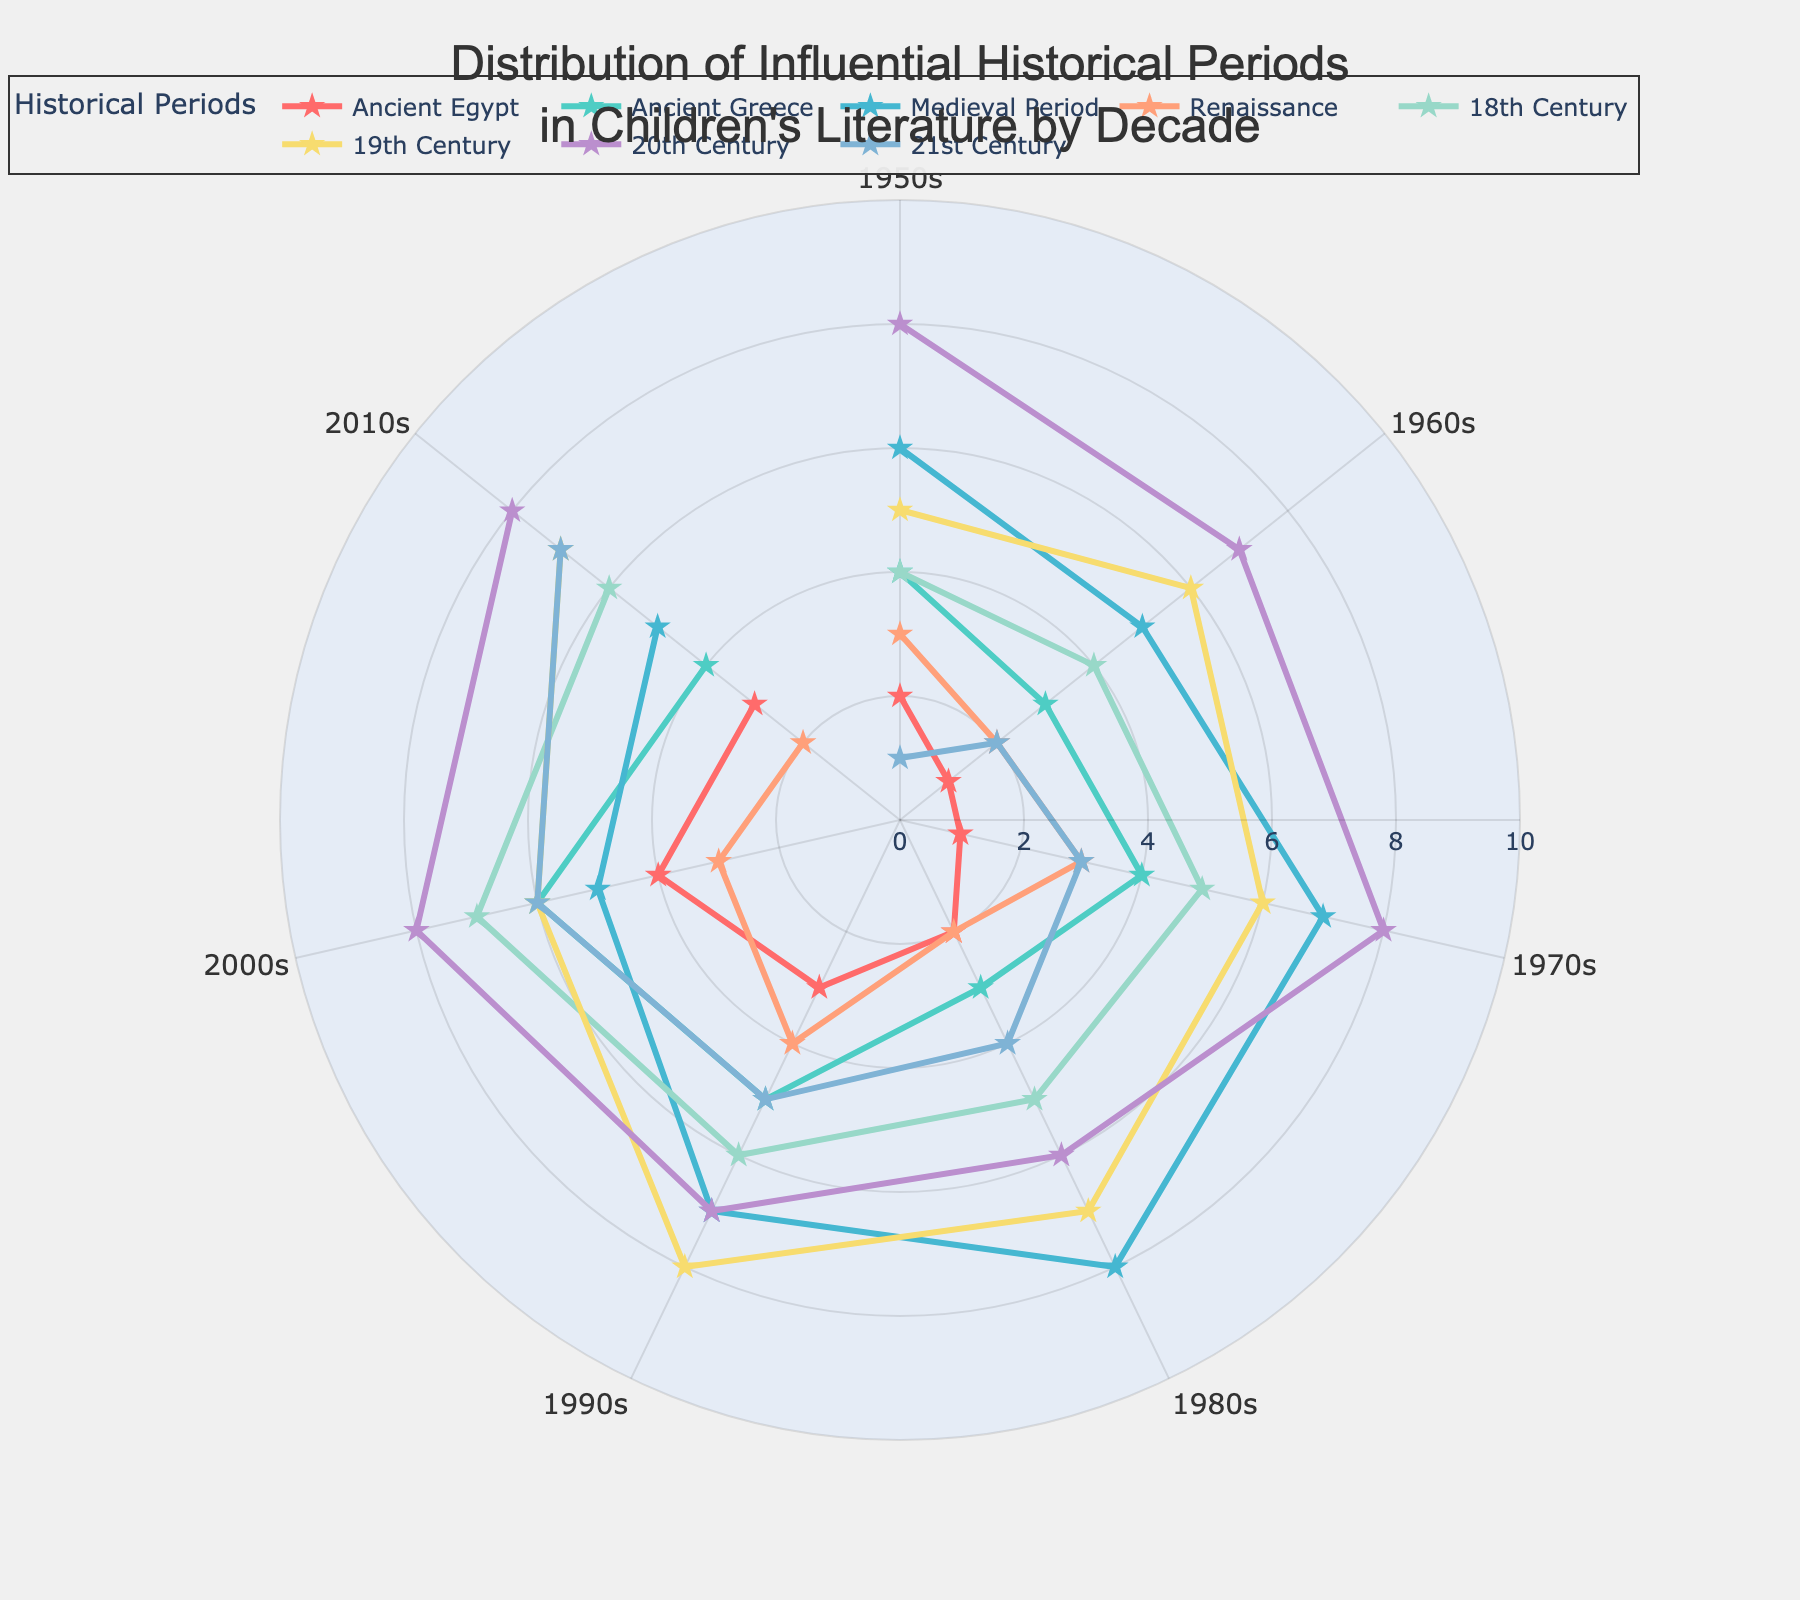what is the title of the figure? The title is typically found at the top center of the figure. It is clearly outlined with larger and bolder text for readability.
Answer: Distribution of Influential Historical Periods in Children's Literature by Decade How many historical periods are depicted in the plot? Each historical period category is distinctively colored, making them easier to count.
Answer: 8 In which decade was literature about the Medieval Period most influential? The radial axis values for the Medieval Period reach the highest point for one specific decade.
Answer: 1990s Which historical period consistently increases in prominence from the 1950s to the 2010s? By observing the trend lines for each historical period, we can identify the one with a steady upward trajectory.
Answer: 21st Century What is the total number of publications for the Ancient Egypt period in the 1960s and the 1970s combined? Sum the values of the Ancient Egypt period for these two specific decades.
Answer: 2 Which decade has the highest combined publications for all historical periods? Sum the values for each period per decade and identify the highest total.
Answer: 2010s Is the Renaissance period more influential in the 2000s or in the 2010s? Compare the radial values for the Renaissance period between the 2000s and 2010s.
Answer: 2000s By what value did the influence of the 18th Century period increase from the 1950s to the 2000s? Subtract the 1950s value from the 2000s value for the 18th Century period.
Answer: 3 Which historical period showed a spike in publications in the 1990s but then a decrease in the 2000s? Identify the historical period with an upward trend in the 1990s followed by a downward trend in the 2000s.
Answer: Medieval Period Is there any historical period that has the same number of publications in both the 2010s and the 1950s? Compare the values for all historical periods in the 2010s to those in the 1950s.
Answer: Yes, the 19th Century period 